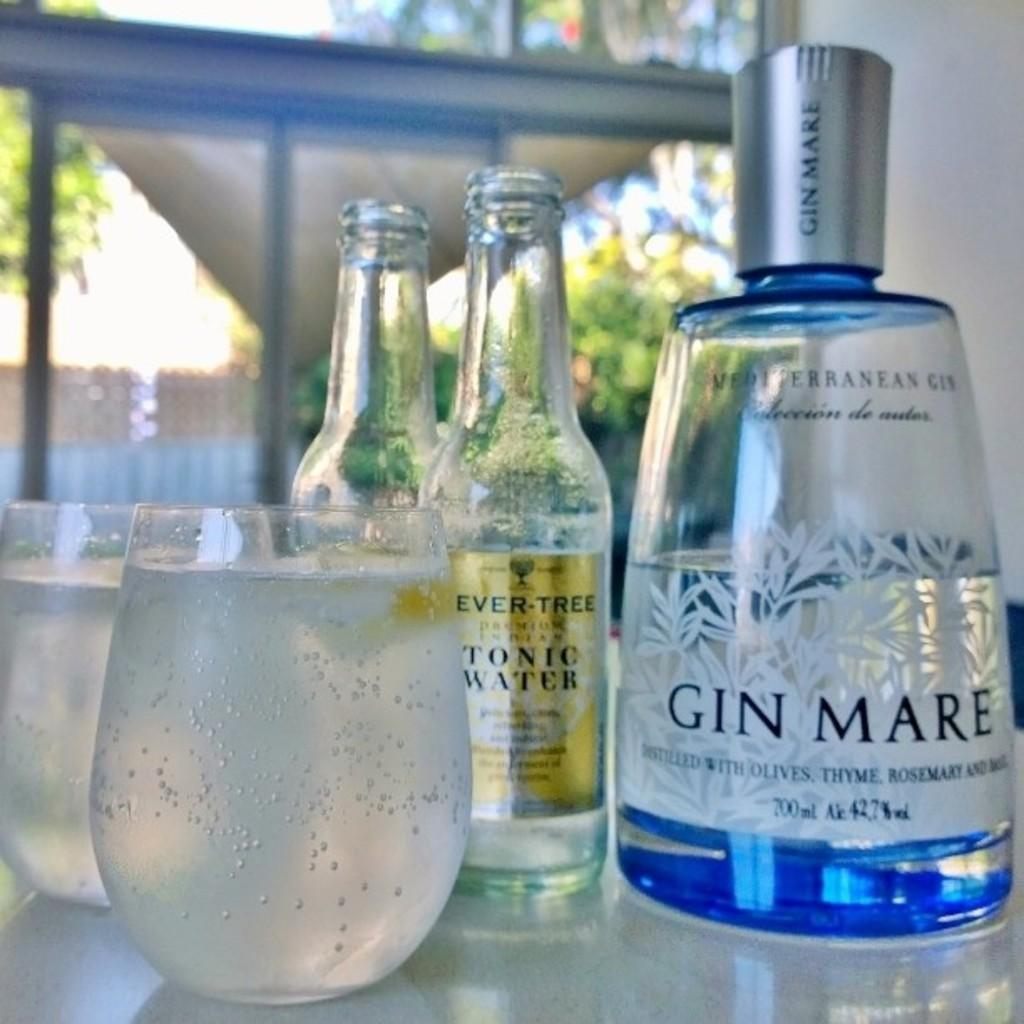<image>
Provide a brief description of the given image. Bottles of Gin Mare and Tonic Water are poured into glasses on a table. 